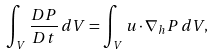<formula> <loc_0><loc_0><loc_500><loc_500>\int _ { V } \frac { D P } { D t } \, d V = \int _ { V } { u } \cdot \nabla _ { h } P \, d V ,</formula> 